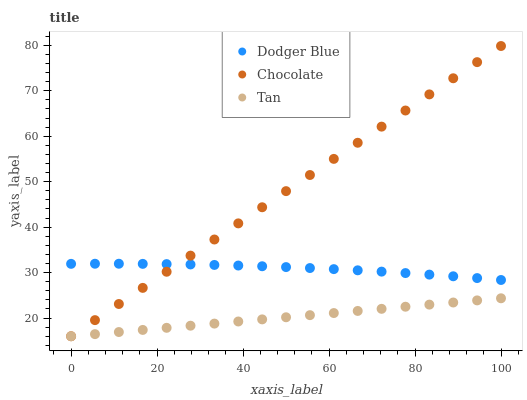Does Tan have the minimum area under the curve?
Answer yes or no. Yes. Does Chocolate have the maximum area under the curve?
Answer yes or no. Yes. Does Dodger Blue have the minimum area under the curve?
Answer yes or no. No. Does Dodger Blue have the maximum area under the curve?
Answer yes or no. No. Is Tan the smoothest?
Answer yes or no. Yes. Is Dodger Blue the roughest?
Answer yes or no. Yes. Is Chocolate the smoothest?
Answer yes or no. No. Is Chocolate the roughest?
Answer yes or no. No. Does Tan have the lowest value?
Answer yes or no. Yes. Does Dodger Blue have the lowest value?
Answer yes or no. No. Does Chocolate have the highest value?
Answer yes or no. Yes. Does Dodger Blue have the highest value?
Answer yes or no. No. Is Tan less than Dodger Blue?
Answer yes or no. Yes. Is Dodger Blue greater than Tan?
Answer yes or no. Yes. Does Chocolate intersect Tan?
Answer yes or no. Yes. Is Chocolate less than Tan?
Answer yes or no. No. Is Chocolate greater than Tan?
Answer yes or no. No. Does Tan intersect Dodger Blue?
Answer yes or no. No. 